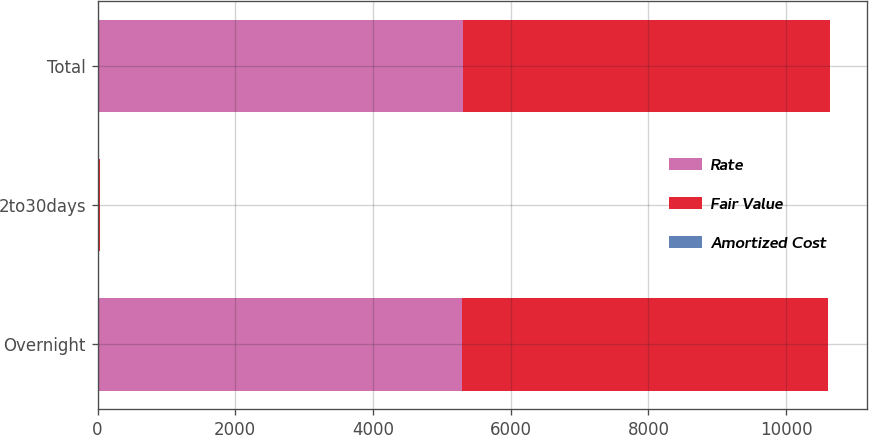Convert chart. <chart><loc_0><loc_0><loc_500><loc_500><stacked_bar_chart><ecel><fcel>Overnight<fcel>2to30days<fcel>Total<nl><fcel>Rate<fcel>5295<fcel>15<fcel>5310<nl><fcel>Fair Value<fcel>5314<fcel>15<fcel>5329<nl><fcel>Amortized Cost<fcel>0.77<fcel>0.83<fcel>0.77<nl></chart> 